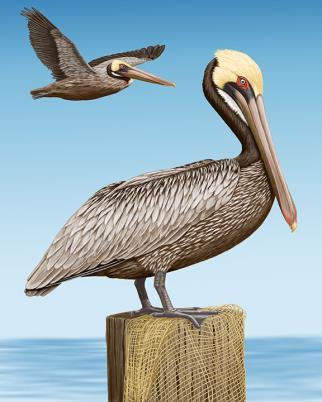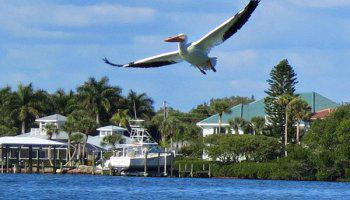The first image is the image on the left, the second image is the image on the right. Examine the images to the left and right. Is the description "Left image shows a pelican perched on a structure in the foreground." accurate? Answer yes or no. Yes. The first image is the image on the left, the second image is the image on the right. Given the left and right images, does the statement "At least two birds are flying." hold true? Answer yes or no. Yes. 